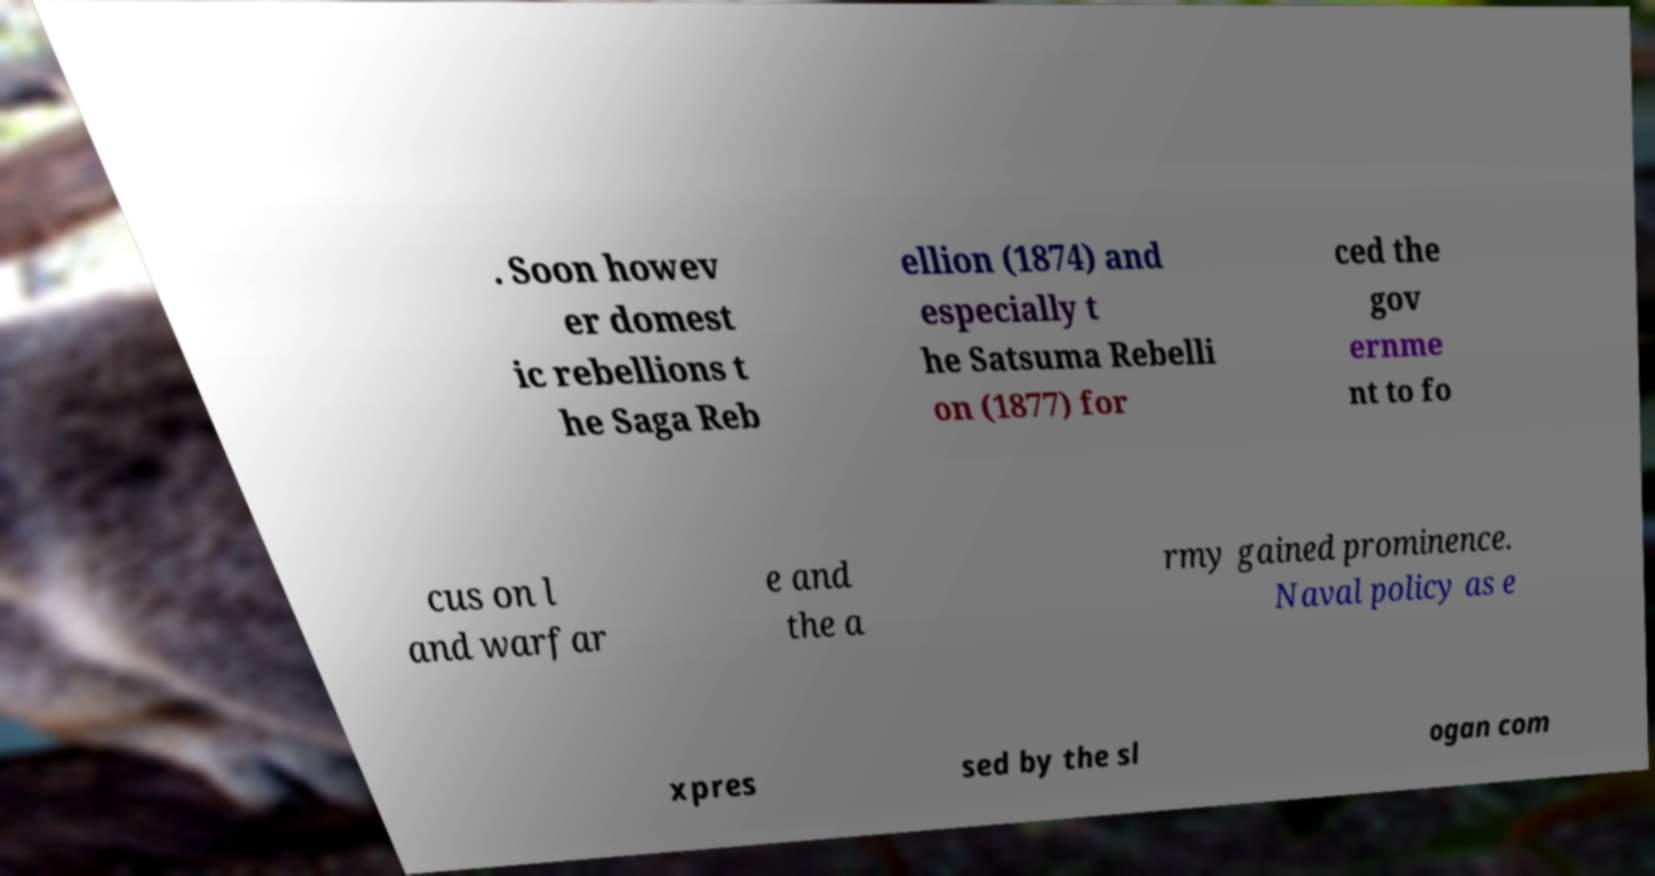Can you accurately transcribe the text from the provided image for me? . Soon howev er domest ic rebellions t he Saga Reb ellion (1874) and especially t he Satsuma Rebelli on (1877) for ced the gov ernme nt to fo cus on l and warfar e and the a rmy gained prominence. Naval policy as e xpres sed by the sl ogan com 